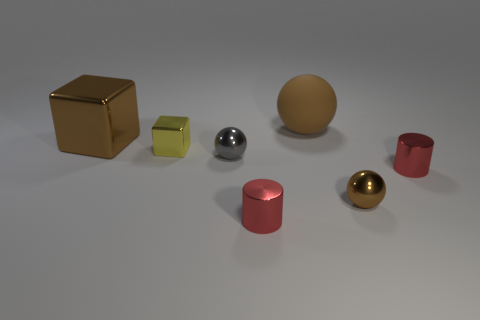Add 2 tiny gray objects. How many objects exist? 9 Subtract all small balls. How many balls are left? 1 Subtract 2 spheres. How many spheres are left? 1 Subtract all balls. How many objects are left? 4 Subtract all gray balls. How many balls are left? 2 Add 4 spheres. How many spheres exist? 7 Subtract 0 blue cubes. How many objects are left? 7 Subtract all purple cylinders. Subtract all blue balls. How many cylinders are left? 2 Subtract all purple blocks. How many gray spheres are left? 1 Subtract all small metallic objects. Subtract all tiny gray shiny objects. How many objects are left? 1 